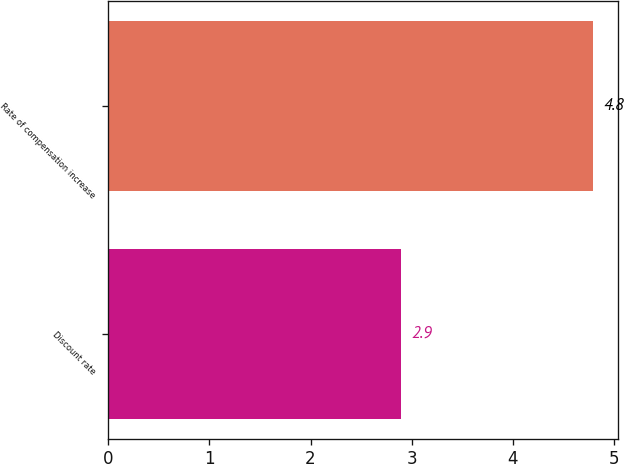<chart> <loc_0><loc_0><loc_500><loc_500><bar_chart><fcel>Discount rate<fcel>Rate of compensation increase<nl><fcel>2.9<fcel>4.8<nl></chart> 